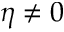<formula> <loc_0><loc_0><loc_500><loc_500>\eta \neq 0</formula> 